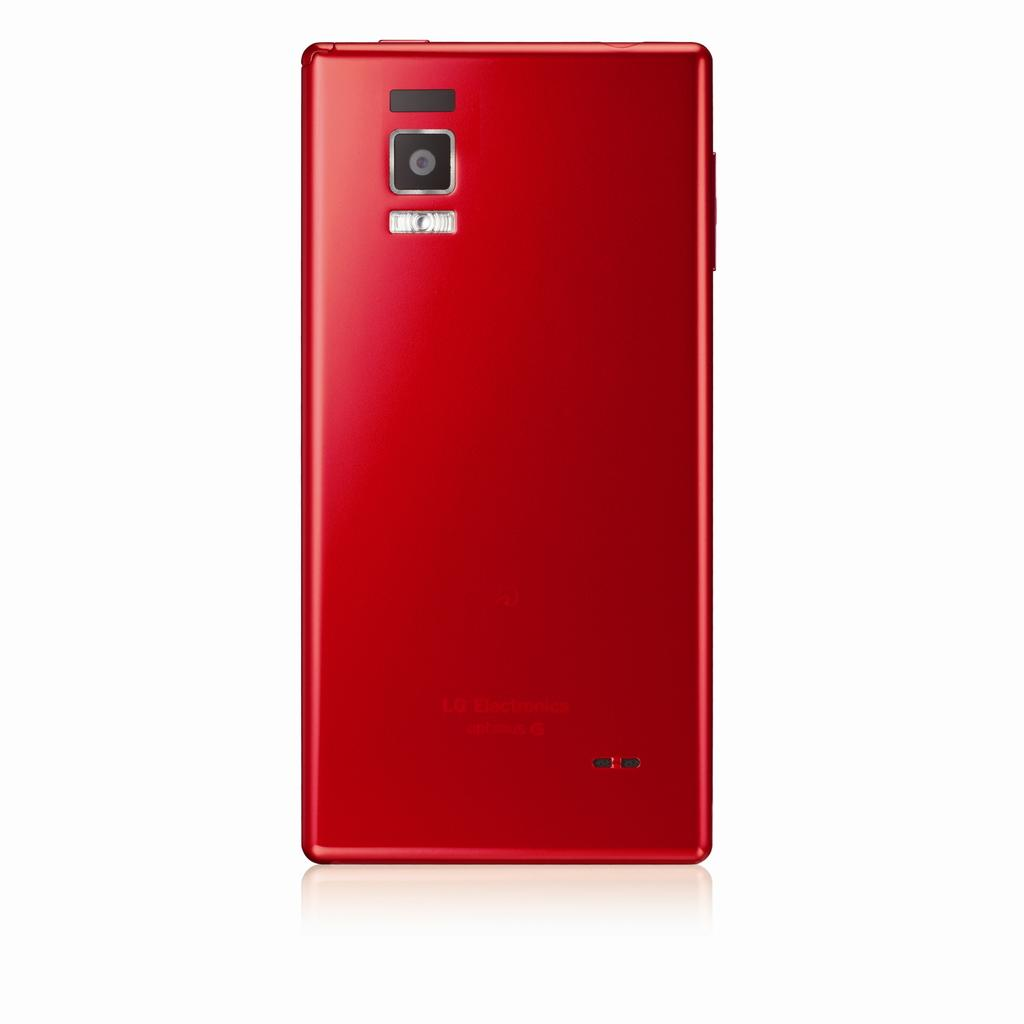<image>
Relay a brief, clear account of the picture shown. A bright red cell phone as the company name LG Electronics on the back. 